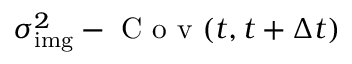<formula> <loc_0><loc_0><loc_500><loc_500>\sigma _ { i m g } ^ { 2 } - C o v ( t , t + \Delta t )</formula> 